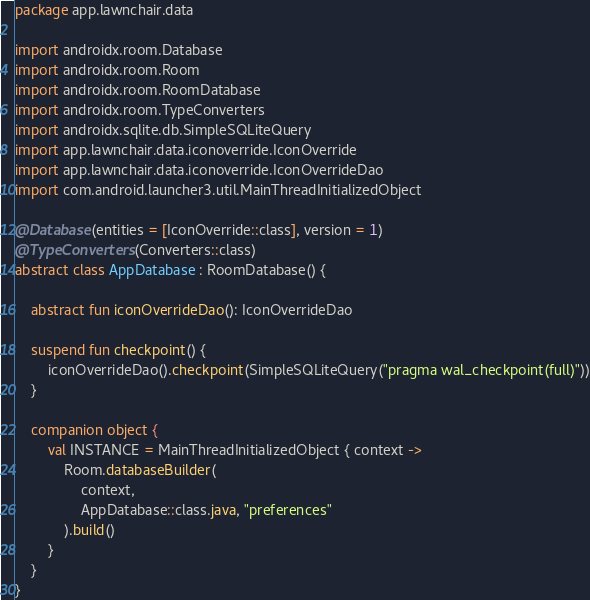<code> <loc_0><loc_0><loc_500><loc_500><_Kotlin_>package app.lawnchair.data

import androidx.room.Database
import androidx.room.Room
import androidx.room.RoomDatabase
import androidx.room.TypeConverters
import androidx.sqlite.db.SimpleSQLiteQuery
import app.lawnchair.data.iconoverride.IconOverride
import app.lawnchair.data.iconoverride.IconOverrideDao
import com.android.launcher3.util.MainThreadInitializedObject

@Database(entities = [IconOverride::class], version = 1)
@TypeConverters(Converters::class)
abstract class AppDatabase : RoomDatabase() {

    abstract fun iconOverrideDao(): IconOverrideDao

    suspend fun checkpoint() {
        iconOverrideDao().checkpoint(SimpleSQLiteQuery("pragma wal_checkpoint(full)"))
    }

    companion object {
        val INSTANCE = MainThreadInitializedObject { context ->
            Room.databaseBuilder(
                context,
                AppDatabase::class.java, "preferences"
            ).build()
        }
    }
}
</code> 